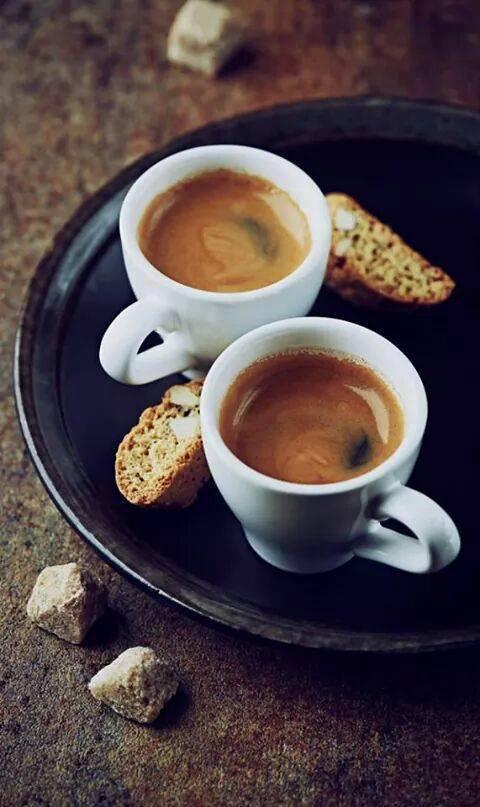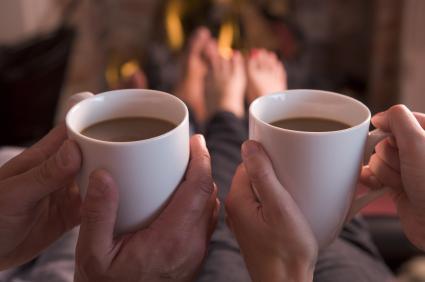The first image is the image on the left, the second image is the image on the right. Assess this claim about the two images: "One image shows human hands wrapped around a cup.". Correct or not? Answer yes or no. Yes. The first image is the image on the left, the second image is the image on the right. Evaluate the accuracy of this statement regarding the images: "Only one image includes human hands with mugs of hot beverages.". Is it true? Answer yes or no. Yes. 